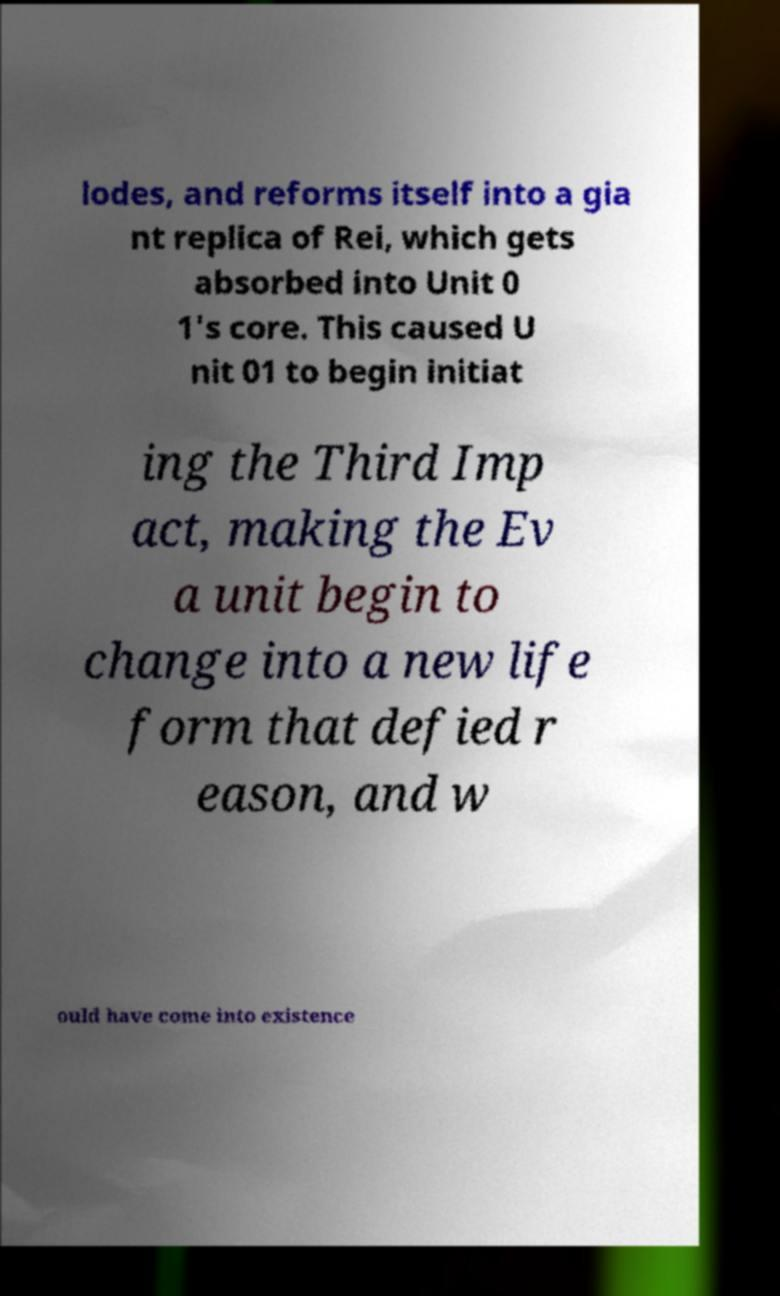Can you accurately transcribe the text from the provided image for me? lodes, and reforms itself into a gia nt replica of Rei, which gets absorbed into Unit 0 1's core. This caused U nit 01 to begin initiat ing the Third Imp act, making the Ev a unit begin to change into a new life form that defied r eason, and w ould have come into existence 